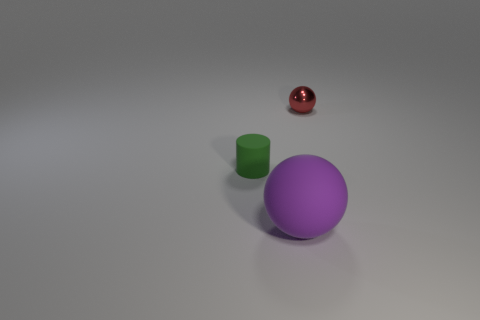Subtract all balls. How many objects are left? 1 Subtract 1 cylinders. How many cylinders are left? 0 Add 2 red cylinders. How many objects exist? 5 Subtract all purple spheres. How many spheres are left? 1 Subtract 0 cyan spheres. How many objects are left? 3 Subtract all cyan spheres. Subtract all green cylinders. How many spheres are left? 2 Subtract all purple cubes. How many red spheres are left? 1 Subtract all big blue matte cylinders. Subtract all red spheres. How many objects are left? 2 Add 1 spheres. How many spheres are left? 3 Add 2 small rubber objects. How many small rubber objects exist? 3 